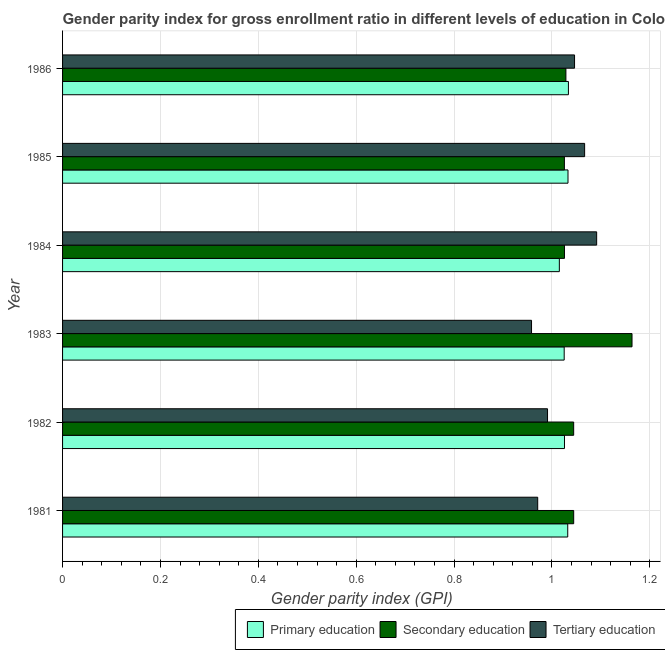Are the number of bars per tick equal to the number of legend labels?
Offer a very short reply. Yes. How many bars are there on the 4th tick from the bottom?
Your answer should be very brief. 3. What is the label of the 2nd group of bars from the top?
Offer a very short reply. 1985. In how many cases, is the number of bars for a given year not equal to the number of legend labels?
Make the answer very short. 0. What is the gender parity index in tertiary education in 1984?
Your response must be concise. 1.09. Across all years, what is the maximum gender parity index in primary education?
Provide a succinct answer. 1.03. Across all years, what is the minimum gender parity index in tertiary education?
Provide a succinct answer. 0.96. In which year was the gender parity index in secondary education maximum?
Offer a terse response. 1983. In which year was the gender parity index in tertiary education minimum?
Make the answer very short. 1983. What is the total gender parity index in tertiary education in the graph?
Your response must be concise. 6.12. What is the difference between the gender parity index in tertiary education in 1983 and that in 1985?
Offer a very short reply. -0.11. What is the difference between the gender parity index in secondary education in 1983 and the gender parity index in tertiary education in 1982?
Ensure brevity in your answer.  0.17. In the year 1983, what is the difference between the gender parity index in tertiary education and gender parity index in secondary education?
Make the answer very short. -0.2. In how many years, is the gender parity index in secondary education greater than 1.08 ?
Offer a terse response. 1. What is the ratio of the gender parity index in tertiary education in 1983 to that in 1986?
Your answer should be very brief. 0.92. Is the gender parity index in primary education in 1981 less than that in 1982?
Make the answer very short. No. What is the difference between the highest and the second highest gender parity index in primary education?
Your answer should be compact. 0. What is the difference between the highest and the lowest gender parity index in tertiary education?
Make the answer very short. 0.13. In how many years, is the gender parity index in secondary education greater than the average gender parity index in secondary education taken over all years?
Provide a short and direct response. 1. Is the sum of the gender parity index in secondary education in 1981 and 1984 greater than the maximum gender parity index in primary education across all years?
Your response must be concise. Yes. What does the 1st bar from the top in 1984 represents?
Provide a succinct answer. Tertiary education. What does the 2nd bar from the bottom in 1986 represents?
Make the answer very short. Secondary education. How many bars are there?
Offer a terse response. 18. Does the graph contain any zero values?
Offer a terse response. No. Does the graph contain grids?
Provide a succinct answer. Yes. What is the title of the graph?
Ensure brevity in your answer.  Gender parity index for gross enrollment ratio in different levels of education in Colombia. What is the label or title of the X-axis?
Offer a very short reply. Gender parity index (GPI). What is the label or title of the Y-axis?
Offer a terse response. Year. What is the Gender parity index (GPI) of Primary education in 1981?
Provide a short and direct response. 1.03. What is the Gender parity index (GPI) in Secondary education in 1981?
Keep it short and to the point. 1.04. What is the Gender parity index (GPI) of Tertiary education in 1981?
Your response must be concise. 0.97. What is the Gender parity index (GPI) in Primary education in 1982?
Offer a very short reply. 1.03. What is the Gender parity index (GPI) in Secondary education in 1982?
Keep it short and to the point. 1.04. What is the Gender parity index (GPI) in Tertiary education in 1982?
Make the answer very short. 0.99. What is the Gender parity index (GPI) in Primary education in 1983?
Make the answer very short. 1.03. What is the Gender parity index (GPI) in Secondary education in 1983?
Provide a short and direct response. 1.16. What is the Gender parity index (GPI) in Tertiary education in 1983?
Keep it short and to the point. 0.96. What is the Gender parity index (GPI) of Primary education in 1984?
Keep it short and to the point. 1.02. What is the Gender parity index (GPI) of Secondary education in 1984?
Your answer should be compact. 1.03. What is the Gender parity index (GPI) in Tertiary education in 1984?
Your answer should be compact. 1.09. What is the Gender parity index (GPI) in Primary education in 1985?
Your answer should be very brief. 1.03. What is the Gender parity index (GPI) in Secondary education in 1985?
Ensure brevity in your answer.  1.03. What is the Gender parity index (GPI) in Tertiary education in 1985?
Ensure brevity in your answer.  1.07. What is the Gender parity index (GPI) in Primary education in 1986?
Make the answer very short. 1.03. What is the Gender parity index (GPI) of Secondary education in 1986?
Give a very brief answer. 1.03. What is the Gender parity index (GPI) in Tertiary education in 1986?
Your answer should be very brief. 1.05. Across all years, what is the maximum Gender parity index (GPI) of Primary education?
Keep it short and to the point. 1.03. Across all years, what is the maximum Gender parity index (GPI) of Secondary education?
Give a very brief answer. 1.16. Across all years, what is the maximum Gender parity index (GPI) in Tertiary education?
Your response must be concise. 1.09. Across all years, what is the minimum Gender parity index (GPI) of Primary education?
Your answer should be very brief. 1.02. Across all years, what is the minimum Gender parity index (GPI) of Secondary education?
Provide a short and direct response. 1.03. Across all years, what is the minimum Gender parity index (GPI) in Tertiary education?
Give a very brief answer. 0.96. What is the total Gender parity index (GPI) of Primary education in the graph?
Provide a short and direct response. 6.16. What is the total Gender parity index (GPI) in Secondary education in the graph?
Your answer should be compact. 6.33. What is the total Gender parity index (GPI) of Tertiary education in the graph?
Provide a succinct answer. 6.12. What is the difference between the Gender parity index (GPI) in Primary education in 1981 and that in 1982?
Provide a succinct answer. 0.01. What is the difference between the Gender parity index (GPI) in Tertiary education in 1981 and that in 1982?
Your response must be concise. -0.02. What is the difference between the Gender parity index (GPI) of Primary education in 1981 and that in 1983?
Ensure brevity in your answer.  0.01. What is the difference between the Gender parity index (GPI) in Secondary education in 1981 and that in 1983?
Make the answer very short. -0.12. What is the difference between the Gender parity index (GPI) in Tertiary education in 1981 and that in 1983?
Your answer should be very brief. 0.01. What is the difference between the Gender parity index (GPI) of Primary education in 1981 and that in 1984?
Give a very brief answer. 0.02. What is the difference between the Gender parity index (GPI) of Secondary education in 1981 and that in 1984?
Your answer should be very brief. 0.02. What is the difference between the Gender parity index (GPI) in Tertiary education in 1981 and that in 1984?
Provide a short and direct response. -0.12. What is the difference between the Gender parity index (GPI) in Primary education in 1981 and that in 1985?
Make the answer very short. -0. What is the difference between the Gender parity index (GPI) in Secondary education in 1981 and that in 1985?
Offer a terse response. 0.02. What is the difference between the Gender parity index (GPI) of Tertiary education in 1981 and that in 1985?
Provide a succinct answer. -0.1. What is the difference between the Gender parity index (GPI) of Primary education in 1981 and that in 1986?
Offer a very short reply. -0. What is the difference between the Gender parity index (GPI) in Secondary education in 1981 and that in 1986?
Offer a very short reply. 0.02. What is the difference between the Gender parity index (GPI) in Tertiary education in 1981 and that in 1986?
Offer a very short reply. -0.08. What is the difference between the Gender parity index (GPI) of Primary education in 1982 and that in 1983?
Provide a short and direct response. 0. What is the difference between the Gender parity index (GPI) in Secondary education in 1982 and that in 1983?
Provide a succinct answer. -0.12. What is the difference between the Gender parity index (GPI) in Tertiary education in 1982 and that in 1983?
Provide a succinct answer. 0.03. What is the difference between the Gender parity index (GPI) of Primary education in 1982 and that in 1984?
Your answer should be very brief. 0.01. What is the difference between the Gender parity index (GPI) in Secondary education in 1982 and that in 1984?
Keep it short and to the point. 0.02. What is the difference between the Gender parity index (GPI) in Tertiary education in 1982 and that in 1984?
Your answer should be very brief. -0.1. What is the difference between the Gender parity index (GPI) of Primary education in 1982 and that in 1985?
Make the answer very short. -0.01. What is the difference between the Gender parity index (GPI) in Secondary education in 1982 and that in 1985?
Make the answer very short. 0.02. What is the difference between the Gender parity index (GPI) of Tertiary education in 1982 and that in 1985?
Your answer should be very brief. -0.08. What is the difference between the Gender parity index (GPI) of Primary education in 1982 and that in 1986?
Your answer should be compact. -0.01. What is the difference between the Gender parity index (GPI) in Secondary education in 1982 and that in 1986?
Provide a succinct answer. 0.02. What is the difference between the Gender parity index (GPI) in Tertiary education in 1982 and that in 1986?
Give a very brief answer. -0.06. What is the difference between the Gender parity index (GPI) in Primary education in 1983 and that in 1984?
Offer a terse response. 0.01. What is the difference between the Gender parity index (GPI) in Secondary education in 1983 and that in 1984?
Ensure brevity in your answer.  0.14. What is the difference between the Gender parity index (GPI) of Tertiary education in 1983 and that in 1984?
Keep it short and to the point. -0.13. What is the difference between the Gender parity index (GPI) in Primary education in 1983 and that in 1985?
Keep it short and to the point. -0.01. What is the difference between the Gender parity index (GPI) in Secondary education in 1983 and that in 1985?
Your response must be concise. 0.14. What is the difference between the Gender parity index (GPI) of Tertiary education in 1983 and that in 1985?
Your response must be concise. -0.11. What is the difference between the Gender parity index (GPI) of Primary education in 1983 and that in 1986?
Ensure brevity in your answer.  -0.01. What is the difference between the Gender parity index (GPI) in Secondary education in 1983 and that in 1986?
Your answer should be compact. 0.14. What is the difference between the Gender parity index (GPI) of Tertiary education in 1983 and that in 1986?
Make the answer very short. -0.09. What is the difference between the Gender parity index (GPI) in Primary education in 1984 and that in 1985?
Give a very brief answer. -0.02. What is the difference between the Gender parity index (GPI) in Tertiary education in 1984 and that in 1985?
Keep it short and to the point. 0.02. What is the difference between the Gender parity index (GPI) of Primary education in 1984 and that in 1986?
Your answer should be very brief. -0.02. What is the difference between the Gender parity index (GPI) in Secondary education in 1984 and that in 1986?
Your answer should be compact. -0. What is the difference between the Gender parity index (GPI) in Tertiary education in 1984 and that in 1986?
Your answer should be compact. 0.05. What is the difference between the Gender parity index (GPI) of Primary education in 1985 and that in 1986?
Your answer should be very brief. -0. What is the difference between the Gender parity index (GPI) in Secondary education in 1985 and that in 1986?
Make the answer very short. -0. What is the difference between the Gender parity index (GPI) of Tertiary education in 1985 and that in 1986?
Provide a succinct answer. 0.02. What is the difference between the Gender parity index (GPI) in Primary education in 1981 and the Gender parity index (GPI) in Secondary education in 1982?
Ensure brevity in your answer.  -0.01. What is the difference between the Gender parity index (GPI) in Primary education in 1981 and the Gender parity index (GPI) in Tertiary education in 1982?
Your response must be concise. 0.04. What is the difference between the Gender parity index (GPI) in Secondary education in 1981 and the Gender parity index (GPI) in Tertiary education in 1982?
Your answer should be compact. 0.05. What is the difference between the Gender parity index (GPI) in Primary education in 1981 and the Gender parity index (GPI) in Secondary education in 1983?
Provide a short and direct response. -0.13. What is the difference between the Gender parity index (GPI) in Primary education in 1981 and the Gender parity index (GPI) in Tertiary education in 1983?
Your response must be concise. 0.07. What is the difference between the Gender parity index (GPI) in Secondary education in 1981 and the Gender parity index (GPI) in Tertiary education in 1983?
Keep it short and to the point. 0.09. What is the difference between the Gender parity index (GPI) of Primary education in 1981 and the Gender parity index (GPI) of Secondary education in 1984?
Your response must be concise. 0.01. What is the difference between the Gender parity index (GPI) of Primary education in 1981 and the Gender parity index (GPI) of Tertiary education in 1984?
Provide a short and direct response. -0.06. What is the difference between the Gender parity index (GPI) of Secondary education in 1981 and the Gender parity index (GPI) of Tertiary education in 1984?
Your response must be concise. -0.05. What is the difference between the Gender parity index (GPI) of Primary education in 1981 and the Gender parity index (GPI) of Secondary education in 1985?
Provide a short and direct response. 0.01. What is the difference between the Gender parity index (GPI) of Primary education in 1981 and the Gender parity index (GPI) of Tertiary education in 1985?
Ensure brevity in your answer.  -0.03. What is the difference between the Gender parity index (GPI) of Secondary education in 1981 and the Gender parity index (GPI) of Tertiary education in 1985?
Offer a very short reply. -0.02. What is the difference between the Gender parity index (GPI) in Primary education in 1981 and the Gender parity index (GPI) in Secondary education in 1986?
Your response must be concise. 0. What is the difference between the Gender parity index (GPI) of Primary education in 1981 and the Gender parity index (GPI) of Tertiary education in 1986?
Make the answer very short. -0.01. What is the difference between the Gender parity index (GPI) in Secondary education in 1981 and the Gender parity index (GPI) in Tertiary education in 1986?
Your answer should be very brief. -0. What is the difference between the Gender parity index (GPI) of Primary education in 1982 and the Gender parity index (GPI) of Secondary education in 1983?
Ensure brevity in your answer.  -0.14. What is the difference between the Gender parity index (GPI) in Primary education in 1982 and the Gender parity index (GPI) in Tertiary education in 1983?
Give a very brief answer. 0.07. What is the difference between the Gender parity index (GPI) in Secondary education in 1982 and the Gender parity index (GPI) in Tertiary education in 1983?
Provide a short and direct response. 0.09. What is the difference between the Gender parity index (GPI) of Primary education in 1982 and the Gender parity index (GPI) of Secondary education in 1984?
Make the answer very short. 0. What is the difference between the Gender parity index (GPI) of Primary education in 1982 and the Gender parity index (GPI) of Tertiary education in 1984?
Keep it short and to the point. -0.07. What is the difference between the Gender parity index (GPI) of Secondary education in 1982 and the Gender parity index (GPI) of Tertiary education in 1984?
Give a very brief answer. -0.05. What is the difference between the Gender parity index (GPI) of Primary education in 1982 and the Gender parity index (GPI) of Tertiary education in 1985?
Your answer should be very brief. -0.04. What is the difference between the Gender parity index (GPI) of Secondary education in 1982 and the Gender parity index (GPI) of Tertiary education in 1985?
Your answer should be very brief. -0.02. What is the difference between the Gender parity index (GPI) in Primary education in 1982 and the Gender parity index (GPI) in Secondary education in 1986?
Your answer should be compact. -0. What is the difference between the Gender parity index (GPI) in Primary education in 1982 and the Gender parity index (GPI) in Tertiary education in 1986?
Provide a succinct answer. -0.02. What is the difference between the Gender parity index (GPI) of Secondary education in 1982 and the Gender parity index (GPI) of Tertiary education in 1986?
Provide a short and direct response. -0. What is the difference between the Gender parity index (GPI) of Primary education in 1983 and the Gender parity index (GPI) of Secondary education in 1984?
Make the answer very short. -0. What is the difference between the Gender parity index (GPI) in Primary education in 1983 and the Gender parity index (GPI) in Tertiary education in 1984?
Provide a short and direct response. -0.07. What is the difference between the Gender parity index (GPI) of Secondary education in 1983 and the Gender parity index (GPI) of Tertiary education in 1984?
Your answer should be compact. 0.07. What is the difference between the Gender parity index (GPI) in Primary education in 1983 and the Gender parity index (GPI) in Secondary education in 1985?
Keep it short and to the point. -0. What is the difference between the Gender parity index (GPI) of Primary education in 1983 and the Gender parity index (GPI) of Tertiary education in 1985?
Offer a very short reply. -0.04. What is the difference between the Gender parity index (GPI) of Secondary education in 1983 and the Gender parity index (GPI) of Tertiary education in 1985?
Ensure brevity in your answer.  0.1. What is the difference between the Gender parity index (GPI) in Primary education in 1983 and the Gender parity index (GPI) in Secondary education in 1986?
Give a very brief answer. -0. What is the difference between the Gender parity index (GPI) of Primary education in 1983 and the Gender parity index (GPI) of Tertiary education in 1986?
Provide a short and direct response. -0.02. What is the difference between the Gender parity index (GPI) of Secondary education in 1983 and the Gender parity index (GPI) of Tertiary education in 1986?
Your answer should be very brief. 0.12. What is the difference between the Gender parity index (GPI) of Primary education in 1984 and the Gender parity index (GPI) of Secondary education in 1985?
Give a very brief answer. -0.01. What is the difference between the Gender parity index (GPI) of Primary education in 1984 and the Gender parity index (GPI) of Tertiary education in 1985?
Offer a terse response. -0.05. What is the difference between the Gender parity index (GPI) of Secondary education in 1984 and the Gender parity index (GPI) of Tertiary education in 1985?
Give a very brief answer. -0.04. What is the difference between the Gender parity index (GPI) of Primary education in 1984 and the Gender parity index (GPI) of Secondary education in 1986?
Provide a short and direct response. -0.01. What is the difference between the Gender parity index (GPI) of Primary education in 1984 and the Gender parity index (GPI) of Tertiary education in 1986?
Offer a terse response. -0.03. What is the difference between the Gender parity index (GPI) in Secondary education in 1984 and the Gender parity index (GPI) in Tertiary education in 1986?
Keep it short and to the point. -0.02. What is the difference between the Gender parity index (GPI) in Primary education in 1985 and the Gender parity index (GPI) in Secondary education in 1986?
Offer a terse response. 0. What is the difference between the Gender parity index (GPI) in Primary education in 1985 and the Gender parity index (GPI) in Tertiary education in 1986?
Provide a succinct answer. -0.01. What is the difference between the Gender parity index (GPI) in Secondary education in 1985 and the Gender parity index (GPI) in Tertiary education in 1986?
Provide a succinct answer. -0.02. What is the average Gender parity index (GPI) of Primary education per year?
Provide a succinct answer. 1.03. What is the average Gender parity index (GPI) in Secondary education per year?
Give a very brief answer. 1.06. What is the average Gender parity index (GPI) of Tertiary education per year?
Provide a short and direct response. 1.02. In the year 1981, what is the difference between the Gender parity index (GPI) in Primary education and Gender parity index (GPI) in Secondary education?
Make the answer very short. -0.01. In the year 1981, what is the difference between the Gender parity index (GPI) of Primary education and Gender parity index (GPI) of Tertiary education?
Provide a short and direct response. 0.06. In the year 1981, what is the difference between the Gender parity index (GPI) in Secondary education and Gender parity index (GPI) in Tertiary education?
Offer a terse response. 0.07. In the year 1982, what is the difference between the Gender parity index (GPI) of Primary education and Gender parity index (GPI) of Secondary education?
Offer a terse response. -0.02. In the year 1982, what is the difference between the Gender parity index (GPI) in Primary education and Gender parity index (GPI) in Tertiary education?
Your answer should be very brief. 0.03. In the year 1982, what is the difference between the Gender parity index (GPI) in Secondary education and Gender parity index (GPI) in Tertiary education?
Your response must be concise. 0.05. In the year 1983, what is the difference between the Gender parity index (GPI) of Primary education and Gender parity index (GPI) of Secondary education?
Your answer should be very brief. -0.14. In the year 1983, what is the difference between the Gender parity index (GPI) of Primary education and Gender parity index (GPI) of Tertiary education?
Your response must be concise. 0.07. In the year 1983, what is the difference between the Gender parity index (GPI) in Secondary education and Gender parity index (GPI) in Tertiary education?
Provide a short and direct response. 0.21. In the year 1984, what is the difference between the Gender parity index (GPI) in Primary education and Gender parity index (GPI) in Secondary education?
Provide a succinct answer. -0.01. In the year 1984, what is the difference between the Gender parity index (GPI) of Primary education and Gender parity index (GPI) of Tertiary education?
Offer a very short reply. -0.08. In the year 1984, what is the difference between the Gender parity index (GPI) in Secondary education and Gender parity index (GPI) in Tertiary education?
Your response must be concise. -0.07. In the year 1985, what is the difference between the Gender parity index (GPI) in Primary education and Gender parity index (GPI) in Secondary education?
Give a very brief answer. 0.01. In the year 1985, what is the difference between the Gender parity index (GPI) in Primary education and Gender parity index (GPI) in Tertiary education?
Ensure brevity in your answer.  -0.03. In the year 1985, what is the difference between the Gender parity index (GPI) in Secondary education and Gender parity index (GPI) in Tertiary education?
Keep it short and to the point. -0.04. In the year 1986, what is the difference between the Gender parity index (GPI) in Primary education and Gender parity index (GPI) in Secondary education?
Offer a terse response. 0.01. In the year 1986, what is the difference between the Gender parity index (GPI) of Primary education and Gender parity index (GPI) of Tertiary education?
Offer a terse response. -0.01. In the year 1986, what is the difference between the Gender parity index (GPI) in Secondary education and Gender parity index (GPI) in Tertiary education?
Ensure brevity in your answer.  -0.02. What is the ratio of the Gender parity index (GPI) in Primary education in 1981 to that in 1982?
Offer a terse response. 1.01. What is the ratio of the Gender parity index (GPI) of Tertiary education in 1981 to that in 1982?
Your answer should be very brief. 0.98. What is the ratio of the Gender parity index (GPI) of Primary education in 1981 to that in 1983?
Provide a short and direct response. 1.01. What is the ratio of the Gender parity index (GPI) of Secondary education in 1981 to that in 1983?
Give a very brief answer. 0.9. What is the ratio of the Gender parity index (GPI) of Tertiary education in 1981 to that in 1983?
Provide a succinct answer. 1.01. What is the ratio of the Gender parity index (GPI) in Primary education in 1981 to that in 1984?
Ensure brevity in your answer.  1.02. What is the ratio of the Gender parity index (GPI) of Secondary education in 1981 to that in 1984?
Keep it short and to the point. 1.02. What is the ratio of the Gender parity index (GPI) in Tertiary education in 1981 to that in 1984?
Your response must be concise. 0.89. What is the ratio of the Gender parity index (GPI) in Primary education in 1981 to that in 1985?
Offer a very short reply. 1. What is the ratio of the Gender parity index (GPI) of Secondary education in 1981 to that in 1985?
Keep it short and to the point. 1.02. What is the ratio of the Gender parity index (GPI) of Tertiary education in 1981 to that in 1985?
Make the answer very short. 0.91. What is the ratio of the Gender parity index (GPI) of Secondary education in 1981 to that in 1986?
Your response must be concise. 1.02. What is the ratio of the Gender parity index (GPI) of Tertiary education in 1981 to that in 1986?
Provide a short and direct response. 0.93. What is the ratio of the Gender parity index (GPI) of Primary education in 1982 to that in 1983?
Your response must be concise. 1. What is the ratio of the Gender parity index (GPI) in Secondary education in 1982 to that in 1983?
Ensure brevity in your answer.  0.9. What is the ratio of the Gender parity index (GPI) of Tertiary education in 1982 to that in 1983?
Your response must be concise. 1.03. What is the ratio of the Gender parity index (GPI) of Primary education in 1982 to that in 1984?
Your answer should be very brief. 1.01. What is the ratio of the Gender parity index (GPI) in Secondary education in 1982 to that in 1984?
Your answer should be compact. 1.02. What is the ratio of the Gender parity index (GPI) of Tertiary education in 1982 to that in 1984?
Ensure brevity in your answer.  0.91. What is the ratio of the Gender parity index (GPI) of Primary education in 1982 to that in 1985?
Provide a short and direct response. 0.99. What is the ratio of the Gender parity index (GPI) in Secondary education in 1982 to that in 1985?
Give a very brief answer. 1.02. What is the ratio of the Gender parity index (GPI) in Tertiary education in 1982 to that in 1985?
Ensure brevity in your answer.  0.93. What is the ratio of the Gender parity index (GPI) in Primary education in 1982 to that in 1986?
Your answer should be very brief. 0.99. What is the ratio of the Gender parity index (GPI) of Secondary education in 1982 to that in 1986?
Provide a short and direct response. 1.02. What is the ratio of the Gender parity index (GPI) of Tertiary education in 1982 to that in 1986?
Your answer should be compact. 0.95. What is the ratio of the Gender parity index (GPI) in Primary education in 1983 to that in 1984?
Your answer should be compact. 1.01. What is the ratio of the Gender parity index (GPI) of Secondary education in 1983 to that in 1984?
Make the answer very short. 1.13. What is the ratio of the Gender parity index (GPI) of Tertiary education in 1983 to that in 1984?
Ensure brevity in your answer.  0.88. What is the ratio of the Gender parity index (GPI) in Primary education in 1983 to that in 1985?
Offer a terse response. 0.99. What is the ratio of the Gender parity index (GPI) in Secondary education in 1983 to that in 1985?
Offer a very short reply. 1.13. What is the ratio of the Gender parity index (GPI) of Tertiary education in 1983 to that in 1985?
Your answer should be compact. 0.9. What is the ratio of the Gender parity index (GPI) of Primary education in 1983 to that in 1986?
Your answer should be very brief. 0.99. What is the ratio of the Gender parity index (GPI) in Secondary education in 1983 to that in 1986?
Provide a succinct answer. 1.13. What is the ratio of the Gender parity index (GPI) in Tertiary education in 1983 to that in 1986?
Provide a succinct answer. 0.92. What is the ratio of the Gender parity index (GPI) in Primary education in 1984 to that in 1985?
Your answer should be very brief. 0.98. What is the ratio of the Gender parity index (GPI) in Secondary education in 1984 to that in 1985?
Make the answer very short. 1. What is the ratio of the Gender parity index (GPI) in Tertiary education in 1984 to that in 1985?
Give a very brief answer. 1.02. What is the ratio of the Gender parity index (GPI) in Primary education in 1984 to that in 1986?
Your answer should be compact. 0.98. What is the ratio of the Gender parity index (GPI) in Tertiary education in 1984 to that in 1986?
Keep it short and to the point. 1.04. What is the ratio of the Gender parity index (GPI) in Secondary education in 1985 to that in 1986?
Offer a terse response. 1. What is the ratio of the Gender parity index (GPI) of Tertiary education in 1985 to that in 1986?
Ensure brevity in your answer.  1.02. What is the difference between the highest and the second highest Gender parity index (GPI) in Primary education?
Ensure brevity in your answer.  0. What is the difference between the highest and the second highest Gender parity index (GPI) in Secondary education?
Offer a terse response. 0.12. What is the difference between the highest and the second highest Gender parity index (GPI) of Tertiary education?
Keep it short and to the point. 0.02. What is the difference between the highest and the lowest Gender parity index (GPI) in Primary education?
Keep it short and to the point. 0.02. What is the difference between the highest and the lowest Gender parity index (GPI) in Secondary education?
Your answer should be compact. 0.14. What is the difference between the highest and the lowest Gender parity index (GPI) in Tertiary education?
Make the answer very short. 0.13. 